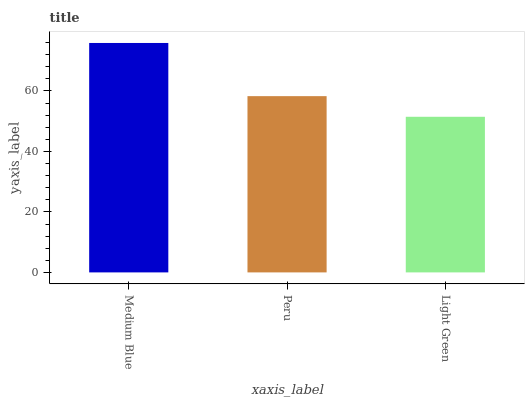Is Peru the minimum?
Answer yes or no. No. Is Peru the maximum?
Answer yes or no. No. Is Medium Blue greater than Peru?
Answer yes or no. Yes. Is Peru less than Medium Blue?
Answer yes or no. Yes. Is Peru greater than Medium Blue?
Answer yes or no. No. Is Medium Blue less than Peru?
Answer yes or no. No. Is Peru the high median?
Answer yes or no. Yes. Is Peru the low median?
Answer yes or no. Yes. Is Medium Blue the high median?
Answer yes or no. No. Is Light Green the low median?
Answer yes or no. No. 